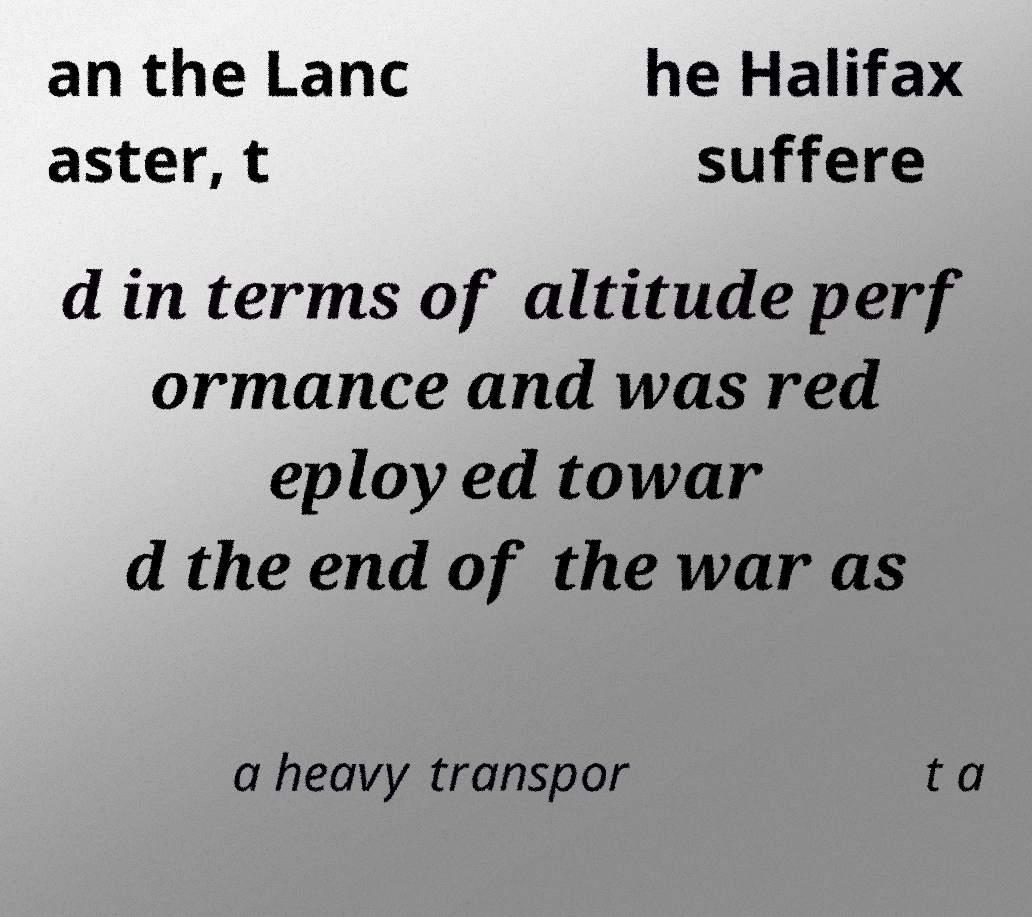What messages or text are displayed in this image? I need them in a readable, typed format. an the Lanc aster, t he Halifax suffere d in terms of altitude perf ormance and was red eployed towar d the end of the war as a heavy transpor t a 